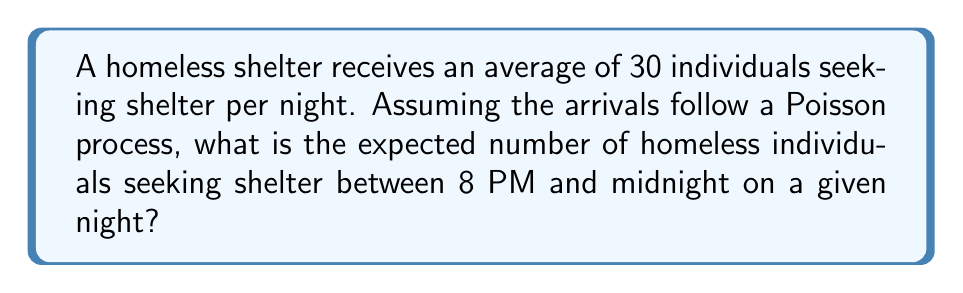What is the answer to this math problem? To solve this problem, we'll use the properties of a Poisson process:

1. The number of arrivals in a given time interval follows a Poisson distribution.
2. The expected number of arrivals is proportional to the length of the time interval.

Let's proceed step-by-step:

1. Calculate the rate parameter λ (lambda) for the entire night:
   λ = 30 individuals per night

2. Determine the proportion of time we're interested in:
   - A full night is typically considered 12 hours (e.g., 8 PM to 8 AM)
   - The time interval of interest is 4 hours (8 PM to midnight)
   - Proportion = 4 hours / 12 hours = 1/3

3. Calculate the expected number of arrivals for the given time interval:
   $E[X] = λ * (proportion of time)$
   $E[X] = 30 * (1/3) = 10$

Therefore, the expected number of homeless individuals seeking shelter between 8 PM and midnight is 10.

This result aligns with the property of Poisson processes that the expected number of events in any interval is proportional to the length of the interval.
Answer: 10 individuals 